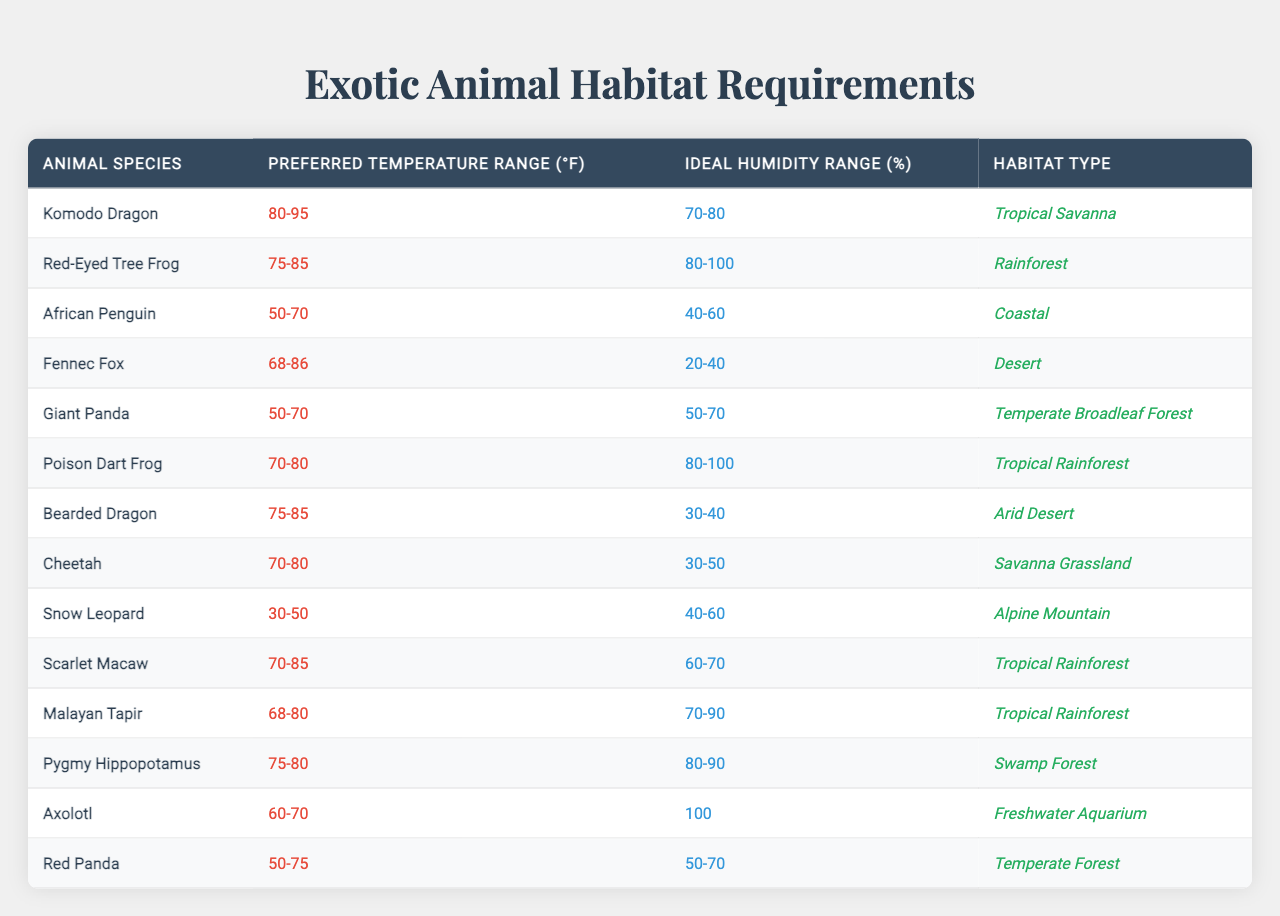What is the ideal humidity range for the African Penguin? According to the table, the ideal humidity range for the African Penguin is listed as 40-60%.
Answer: 40-60% Which animal species prefers a temperature range of 70-80°F? The table shows that both the Cheetah and Poison Dart Frog prefer a temperature range of 70-80°F.
Answer: Cheetah and Poison Dart Frog What habitat type does the Red-Eyed Tree Frog require? The table indicates that the Red-Eyed Tree Frog requires a habitat type classified as Rainforest.
Answer: Rainforest Are there any animals that thrive in a temperature range below 50°F? Yes, the Snow Leopard has a preferred temperature range of 30-50°F, confirming that it thrives in temperatures below 50°F.
Answer: Yes What is the average ideal humidity range for all the tropical rainforest species listed? The ideal humidity ranges for the Red-Eyed Tree Frog (80-100%), Poison Dart Frog (80-100%), Scarlet Macaw (60-70%), and Malayan Tapir (70-90%) are taken. The average of these ranges can be calculated: (90+100+100+70)/4 = 90%.
Answer: 90% Which species has the widest temperature range? The Komodo Dragon prefers a temperature range of 80-95°F, which is wider compared to others.
Answer: Komodo Dragon How many species prefer an ideal humidity range of 80% or more? The Red-Eyed Tree Frog, Poison Dart Frog, Pygmy Hippopotamus, and Malayan Tapir all have ideal humidity ranges of 80% or more, making it a total of four species.
Answer: Four species What is the least tolerant temperature range among the animals listed? The Snow Leopard has a preferred temperature range of 30-50°F, which is the least tolerant compared to others that have higher minimum temperature requirements.
Answer: Snow Leopard How does the temperature range of the Giant Panda compare to that of the Fennec Fox? The Giant Panda prefers a temperature range of 50-70°F while the Fennec Fox prefers 68-86°F, indicating the Fennec Fox can tolerate higher temperatures than the Giant Panda.
Answer: Fennec Fox tolerates higher temperatures Which animal requires a habitat type of Alzheimer's Mountain and also falls in the ideal humidity range of 40-60%? The Snow Leopard is the only animal that requires an Alpine Mountain habitat type and has an ideal humidity range of 40-60%.
Answer: Snow Leopard 